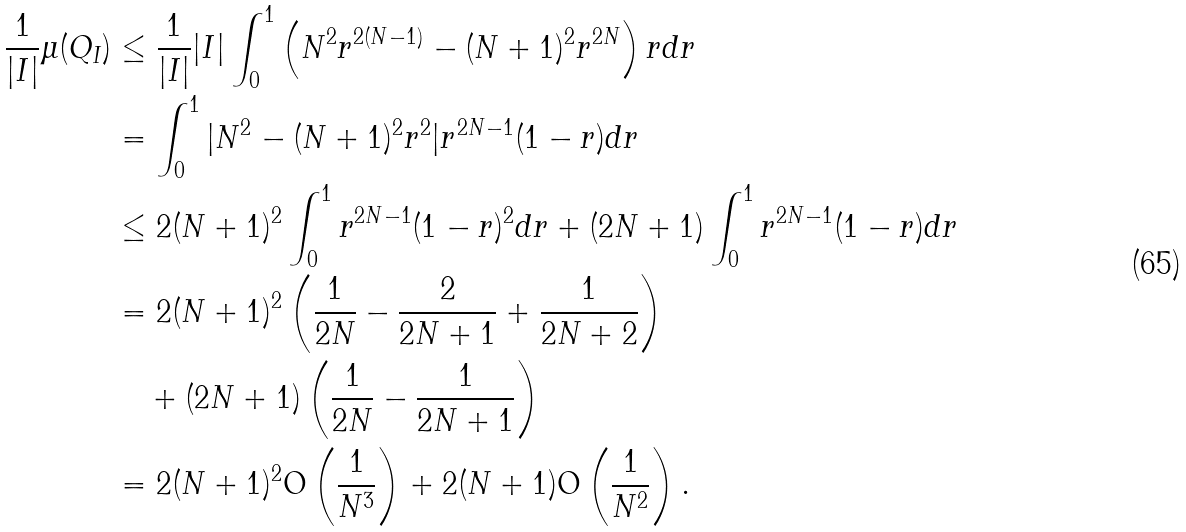<formula> <loc_0><loc_0><loc_500><loc_500>\frac { 1 } { | I | } \mu ( Q _ { I } ) & \leq \frac { 1 } { | I | } | I | \int _ { 0 } ^ { 1 } \left ( N ^ { 2 } r ^ { 2 ( N - 1 ) } - ( N + 1 ) ^ { 2 } r ^ { 2 N } \right ) r d r \\ & = \int ^ { 1 } _ { 0 } | N ^ { 2 } - ( N + 1 ) ^ { 2 } r ^ { 2 } | r ^ { 2 N - 1 } ( 1 - r ) d r \\ & \leq 2 ( N + 1 ) ^ { 2 } \int ^ { 1 } _ { 0 } r ^ { 2 N - 1 } ( 1 - r ) ^ { 2 } d r + ( 2 N + 1 ) \int ^ { 1 } _ { 0 } r ^ { 2 N - 1 } ( 1 - r ) d r \\ & = 2 ( N + 1 ) ^ { 2 } \left ( \frac { 1 } { 2 N } - \frac { 2 } { 2 N + 1 } + \frac { 1 } { 2 N + 2 } \right ) \\ & \quad + ( 2 N + 1 ) \left ( \frac { 1 } { 2 N } - \frac { 1 } { 2 N + 1 } \right ) \\ & = 2 ( N + 1 ) ^ { 2 } \text {O} \left ( \frac { 1 } { N ^ { 3 } } \right ) + 2 ( N + 1 ) \text {O} \left ( \frac { 1 } { N ^ { 2 } } \right ) .</formula> 